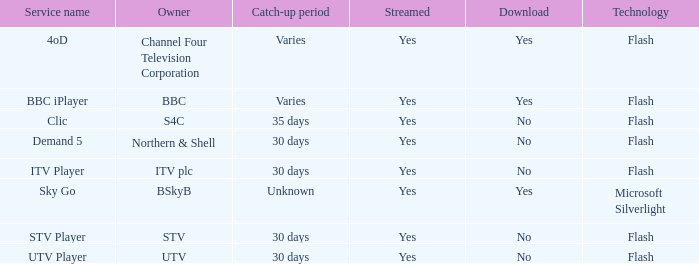What Service Name has UTV as the owner? UTV Player. 